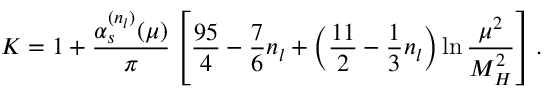Convert formula to latex. <formula><loc_0><loc_0><loc_500><loc_500>K = 1 + \frac { \alpha _ { s } ^ { ( n _ { l } ) } ( \mu ) } { \pi } \left [ \frac { 9 5 } { 4 } - \frac { 7 } { 6 } n _ { l } + \left ( \frac { 1 1 } { 2 } - \frac { 1 } { 3 } n _ { l } \right ) \ln \frac { \mu ^ { 2 } } { M _ { H } ^ { 2 } } \right ] .</formula> 